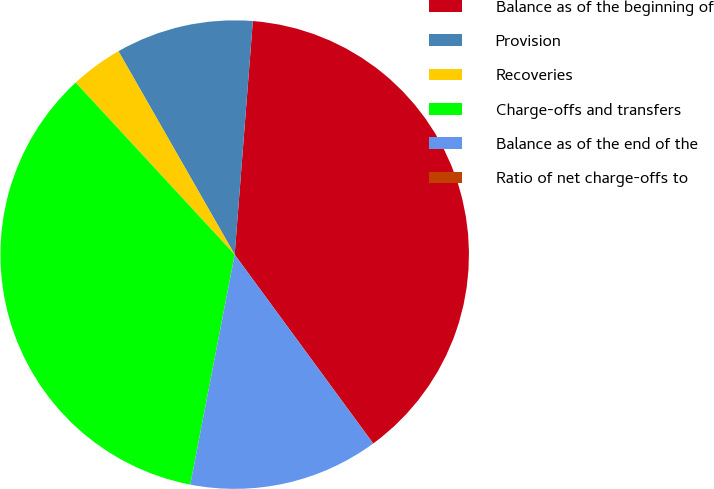<chart> <loc_0><loc_0><loc_500><loc_500><pie_chart><fcel>Balance as of the beginning of<fcel>Provision<fcel>Recoveries<fcel>Charge-offs and transfers<fcel>Balance as of the end of the<fcel>Ratio of net charge-offs to<nl><fcel>38.69%<fcel>9.5%<fcel>3.61%<fcel>35.09%<fcel>13.1%<fcel>0.01%<nl></chart> 